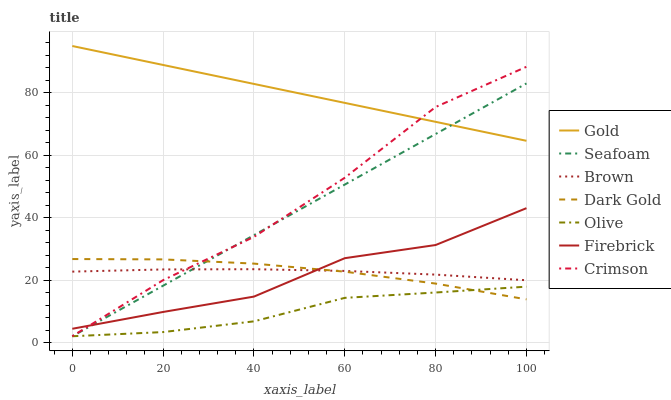Does Olive have the minimum area under the curve?
Answer yes or no. Yes. Does Gold have the maximum area under the curve?
Answer yes or no. Yes. Does Dark Gold have the minimum area under the curve?
Answer yes or no. No. Does Dark Gold have the maximum area under the curve?
Answer yes or no. No. Is Gold the smoothest?
Answer yes or no. Yes. Is Firebrick the roughest?
Answer yes or no. Yes. Is Dark Gold the smoothest?
Answer yes or no. No. Is Dark Gold the roughest?
Answer yes or no. No. Does Seafoam have the lowest value?
Answer yes or no. Yes. Does Dark Gold have the lowest value?
Answer yes or no. No. Does Gold have the highest value?
Answer yes or no. Yes. Does Dark Gold have the highest value?
Answer yes or no. No. Is Olive less than Firebrick?
Answer yes or no. Yes. Is Gold greater than Olive?
Answer yes or no. Yes. Does Firebrick intersect Seafoam?
Answer yes or no. Yes. Is Firebrick less than Seafoam?
Answer yes or no. No. Is Firebrick greater than Seafoam?
Answer yes or no. No. Does Olive intersect Firebrick?
Answer yes or no. No. 